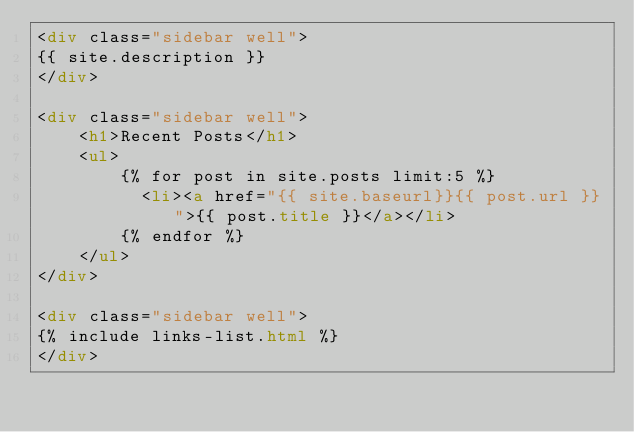<code> <loc_0><loc_0><loc_500><loc_500><_HTML_><div class="sidebar well">
{{ site.description }}
</div>

<div class="sidebar well">
    <h1>Recent Posts</h1>
    <ul>
        {% for post in site.posts limit:5 %}
          <li><a href="{{ site.baseurl}}{{ post.url }}">{{ post.title }}</a></li>
        {% endfor %}
    </ul>
</div>

<div class="sidebar well">
{% include links-list.html %}
</div>
</code> 